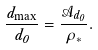<formula> <loc_0><loc_0><loc_500><loc_500>\frac { d _ { \max } } { d _ { 0 } } = \frac { \mathcal { A } _ { d _ { 0 } } } { \rho _ { * } } .</formula> 